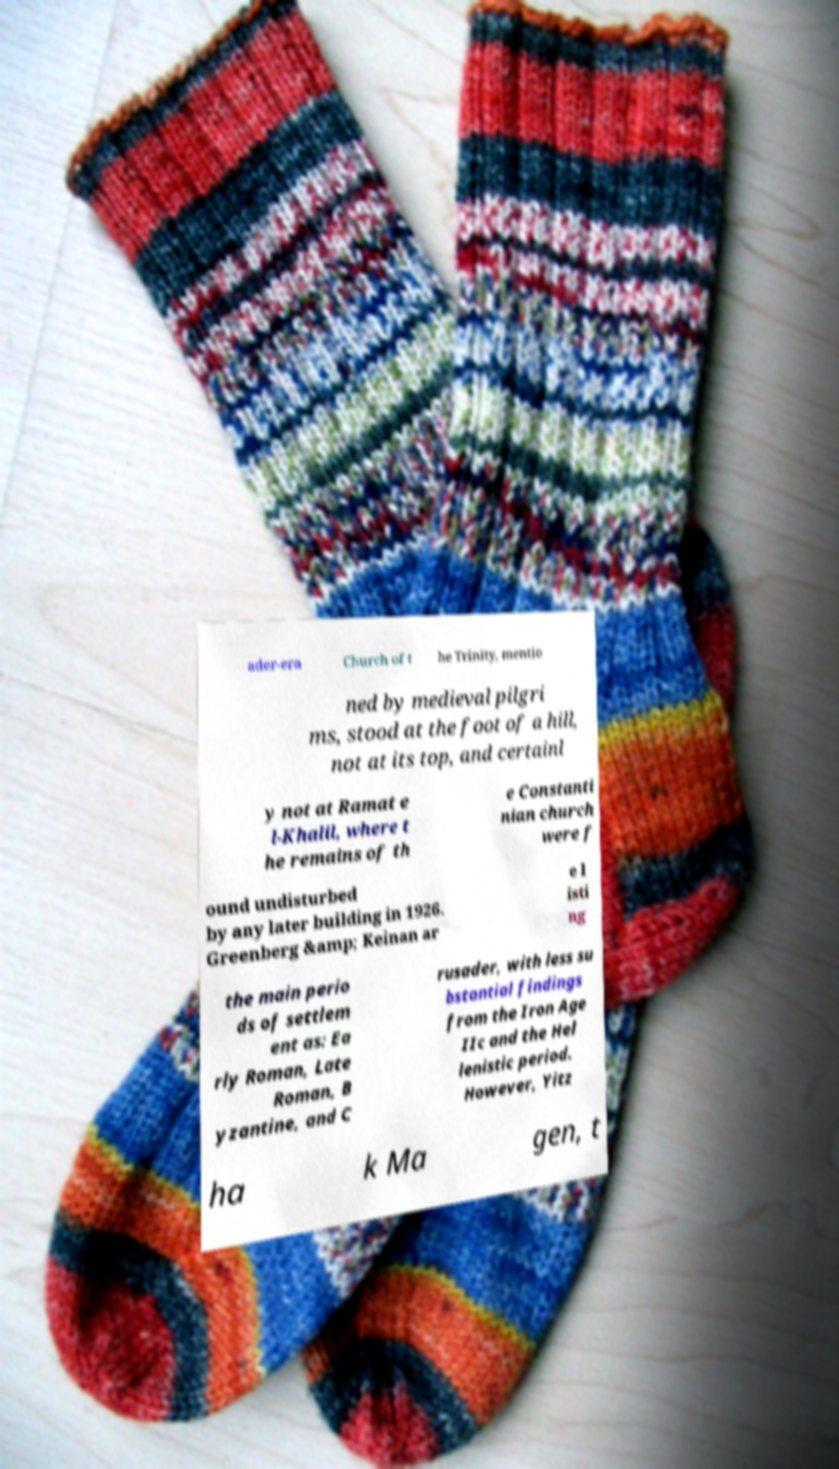Please identify and transcribe the text found in this image. ader-era Church of t he Trinity, mentio ned by medieval pilgri ms, stood at the foot of a hill, not at its top, and certainl y not at Ramat e l-Khalil, where t he remains of th e Constanti nian church were f ound undisturbed by any later building in 1926. Greenberg &amp; Keinan ar e l isti ng the main perio ds of settlem ent as: Ea rly Roman, Late Roman, B yzantine, and C rusader, with less su bstantial findings from the Iron Age IIc and the Hel lenistic period. However, Yitz ha k Ma gen, t 